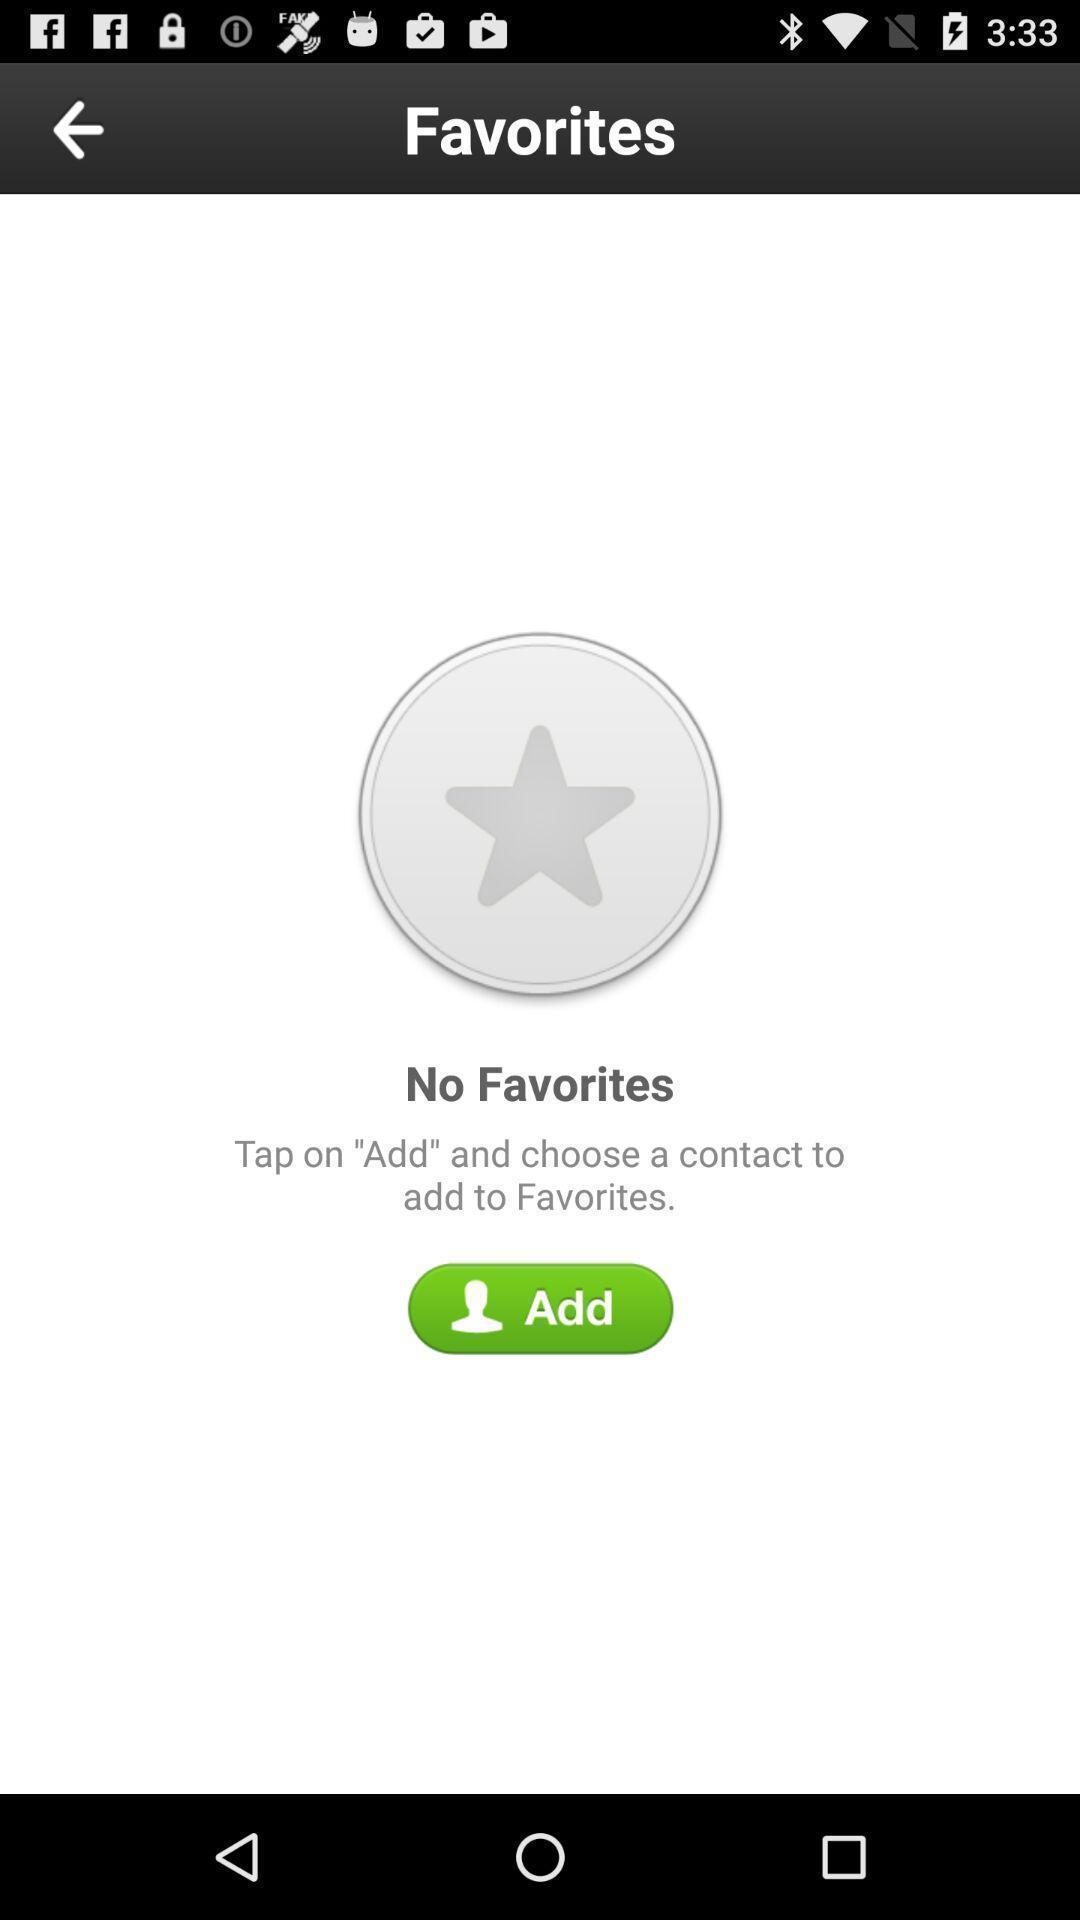Describe the content in this image. Page showing option like add. 